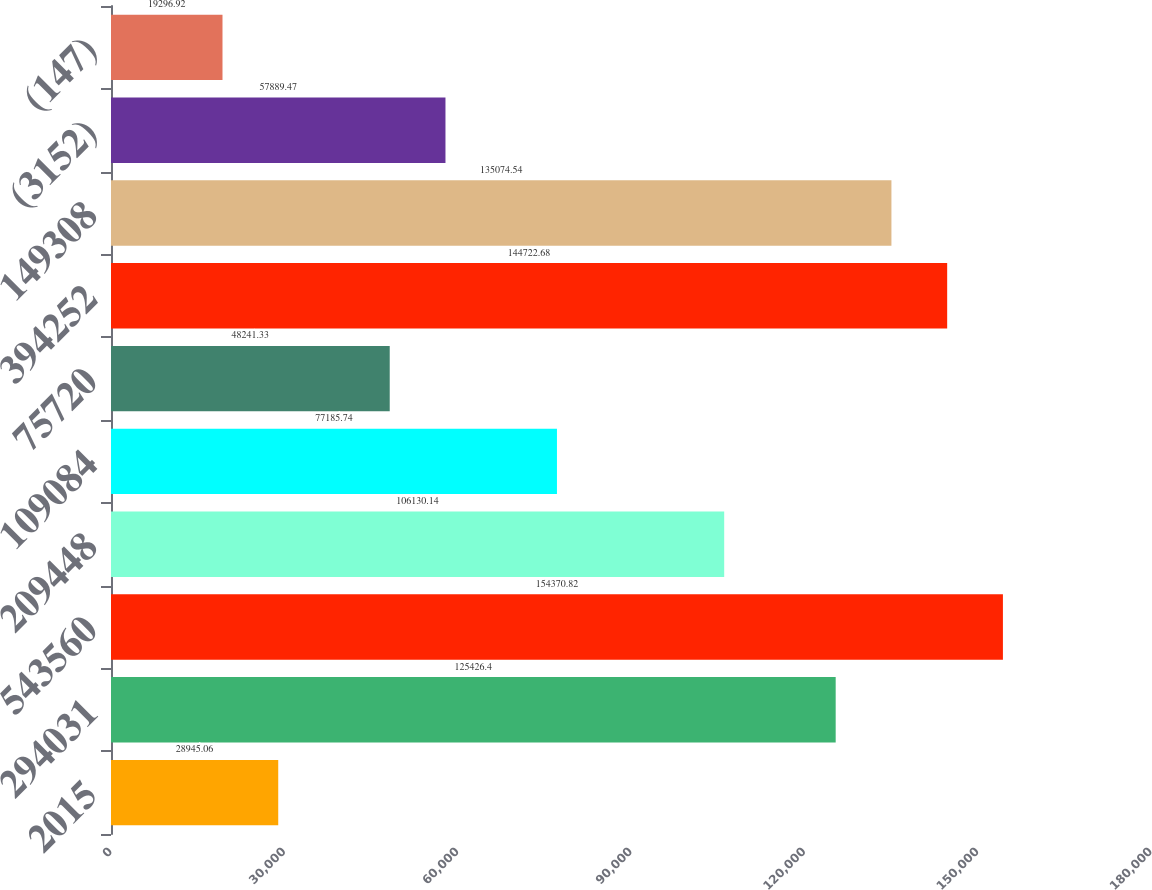<chart> <loc_0><loc_0><loc_500><loc_500><bar_chart><fcel>2015<fcel>294031<fcel>543560<fcel>209448<fcel>109084<fcel>75720<fcel>394252<fcel>149308<fcel>(3152)<fcel>(147)<nl><fcel>28945.1<fcel>125426<fcel>154371<fcel>106130<fcel>77185.7<fcel>48241.3<fcel>144723<fcel>135075<fcel>57889.5<fcel>19296.9<nl></chart> 